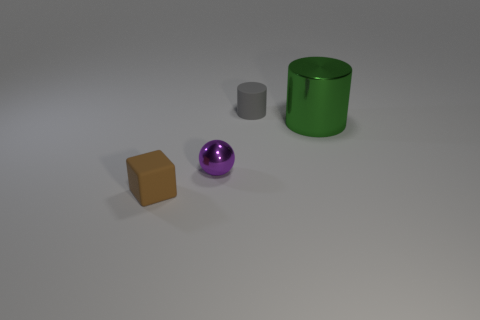Add 3 green blocks. How many objects exist? 7 Subtract all green cylinders. How many cylinders are left? 1 Subtract all blocks. How many objects are left? 3 Subtract 1 spheres. How many spheres are left? 0 Add 4 tiny metallic things. How many tiny metallic things exist? 5 Subtract 0 green cubes. How many objects are left? 4 Subtract all cyan cylinders. Subtract all brown cubes. How many cylinders are left? 2 Subtract all tiny red metallic cylinders. Subtract all small purple metal spheres. How many objects are left? 3 Add 1 small gray matte cylinders. How many small gray matte cylinders are left? 2 